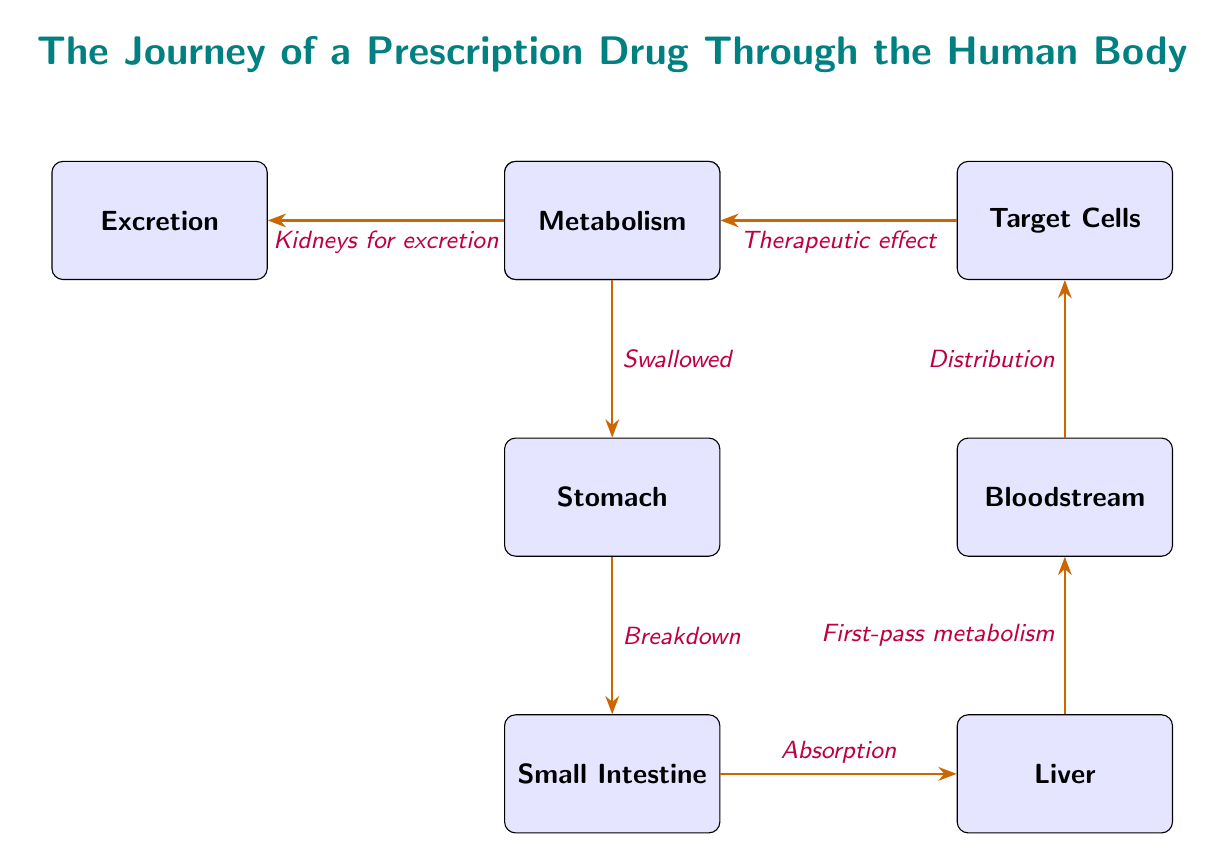What is the starting point of the prescription drug journey? The starting point is "Oral Ingestion," which is the first node in the diagram showing where the journey begins.
Answer: Oral Ingestion What is the destination of the drug before it enters the bloodstream? The node before the bloodstream is the "Liver," which is where the drug goes after passing through the small intestine.
Answer: Liver How many main steps are depicted in the journey of the drug? Counting the nodes, there are a total of eight steps, including oral ingestion and excretion.
Answer: Eight What happens to the drug in the stomach? The drug undergoes "Breakdown" in the stomach, which is shown as the connecting edge from the stomach to the small intestine.
Answer: Breakdown What process occurs after the drug is absorbed in the small intestine? After absorption, the next process is "First-pass metabolism," which takes place in the liver as indicated by the arrow connecting the small intestine to the liver.
Answer: First-pass metabolism Where do the therapeutic effects of the drug occur? The therapeutic effects occur at the "Target Cells," which is the node following the bloodstream in the diagram.
Answer: Target Cells What is the relationship between "Liver" and "Bloodstream" in the diagram? The relationship indicates that after the drug undergoes first-pass metabolism in the liver, it moves into the bloodstream, as shown by the connecting arrow.
Answer: First-pass metabolism What is the final step in the drug's journey? The final step is "Excretion," which is where the drug is processed by the kidneys after its therapeutic effect.
Answer: Excretion 